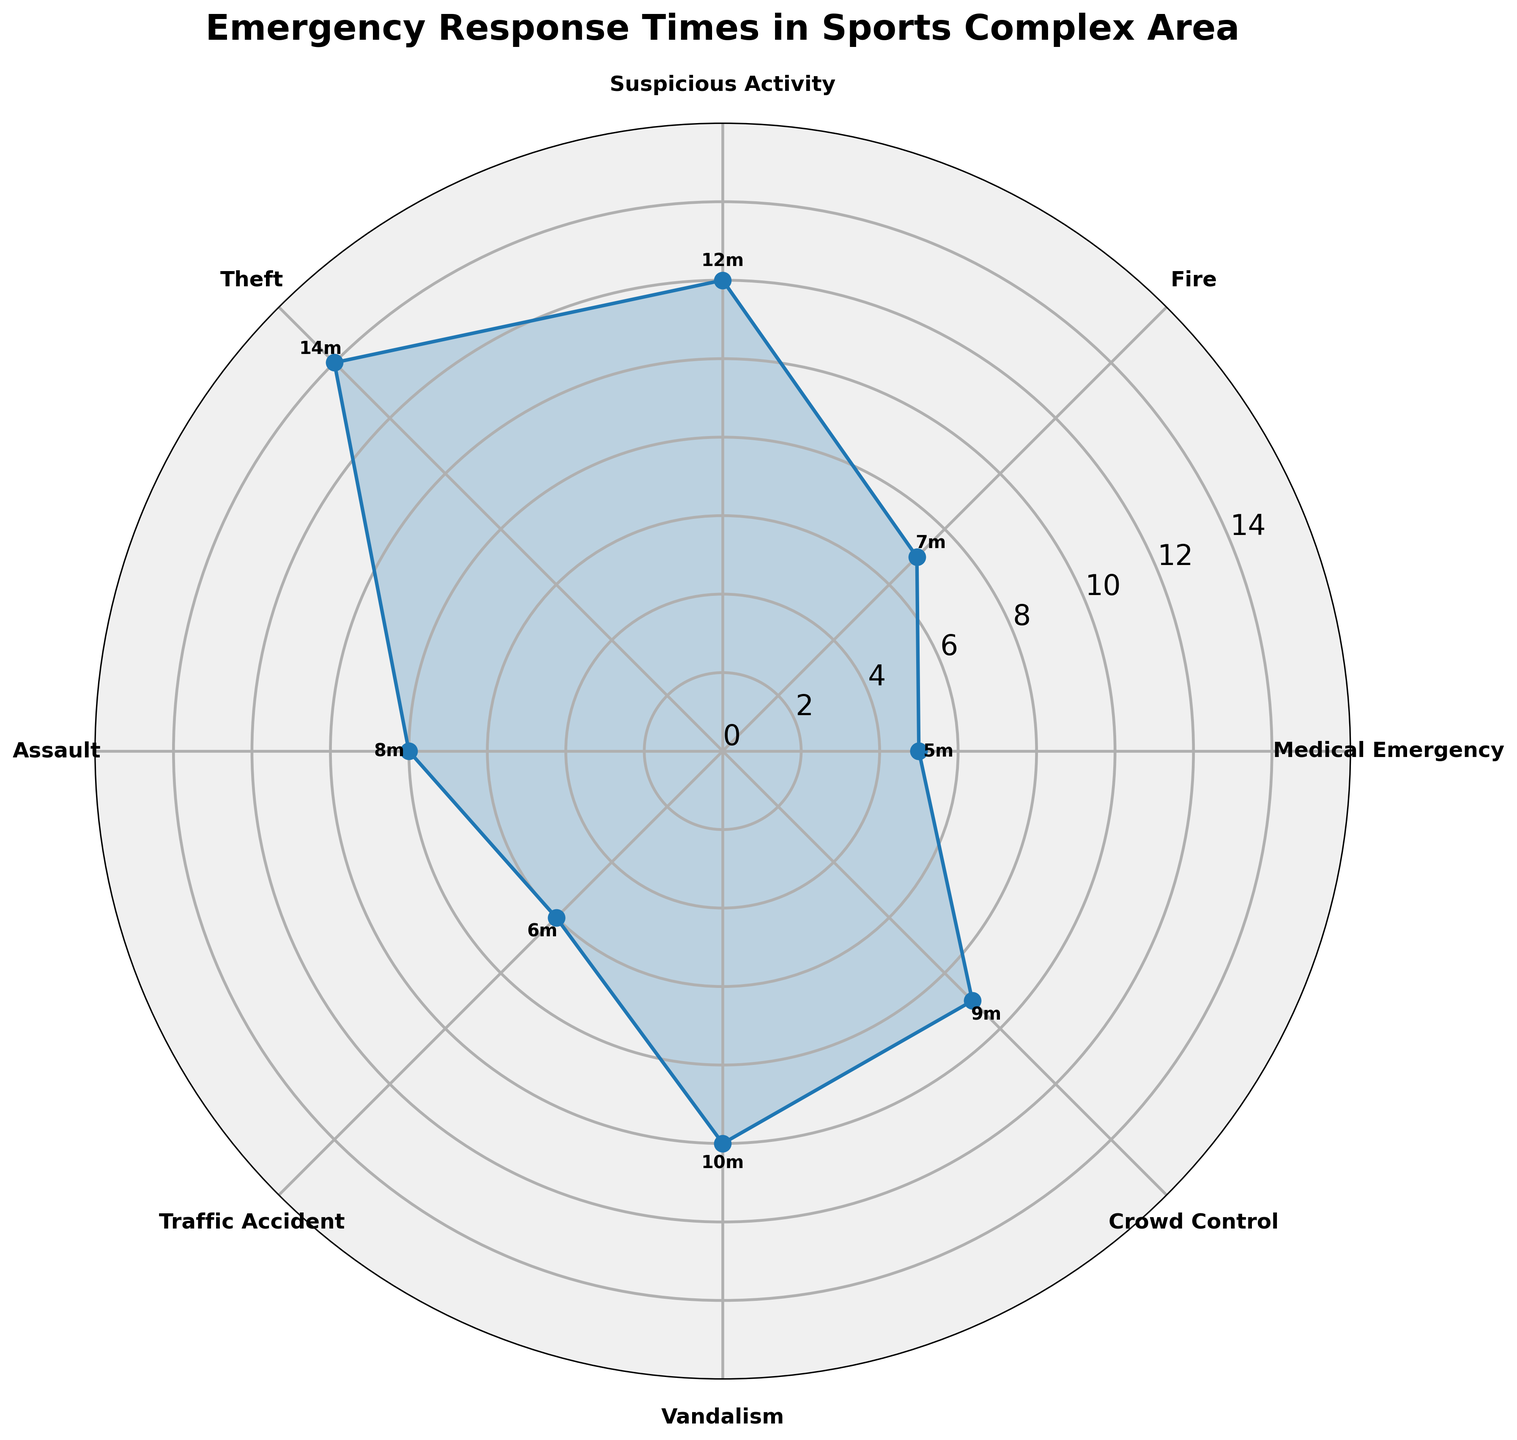Which type of emergency call has the shortest average response time? The shortest average response time can be determined by looking at the smallest value along the radial axis. According to the plot, the category with the shortest response time is Medical Emergency at 5 minutes.
Answer: Medical Emergency What is the average response time for Vandalism? To find the average response time for Vandalism, locate its position on the chart and read the corresponding radial value. The average response time for Vandalism is 10 minutes.
Answer: 10 minutes Which type of emergency call has the longest average response time? The longest average response time can be determined by looking at the largest value along the radial axis. According to the plot, the category with the longest response time is Theft at 14 minutes.
Answer: Theft What is the difference in average response times between Suspicious Activity and Fire? The average response time for Suspicious Activity is 12 minutes, and for Fire, it is 7 minutes. The difference is calculated as 12 - 7 = 5 minutes.
Answer: 5 minutes Are there more calls with an average response time greater than or equal to 10 minutes or less than 10 minutes? Count the number of categories with average response times greater than or equal to 10 minutes and compare it to those less than 10 minutes. Categories greater than or equal to 10 minutes: Suspicious Activity, Theft, Vandalism, Crowd Control. Categories less than 10 minutes: Medical Emergency, Fire, Traffic Accident, Assault. Both have 4 categories each.
Answer: Equal Which two types of emergency calls have the closest average response times? Compare the average response times of all categories to determine the smallest difference. Traffic Accident (6 minutes) and Medical Emergency (5 minutes) are the closest, with a difference of 1 minute.
Answer: Traffic Accident and Medical Emergency What is the median response time for all emergency call types? To calculate the median, arrange the response times in ascending order: 5, 6, 7, 8, 9, 10, 12, 14. Since there are 8 values, the median is the average of the 4th and 5th values: (8 + 9) / 2 = 8.5 minutes.
Answer: 8.5 minutes Which emergency call types have response times above and below the median? First, find the median response time, which is 8.5 minutes. Categories above 8.5 minutes: Suspicious Activity, Theft, Vandalism, Crowd Control. Categories below 8.5 minutes: Medical Emergency, Fire, Traffic Accident, Assault.
Answer: Above: Suspicious Activity, Theft, Vandalism, Crowd Control; Below: Medical Emergency, Fire, Traffic Accident, Assault What is the total combined response time for all emergency call types? Sum the average response times for all categories: 5 + 7 + 12 + 14 + 8 + 6 + 10 + 9 = 71 minutes total combined response time.
Answer: 71 minutes 